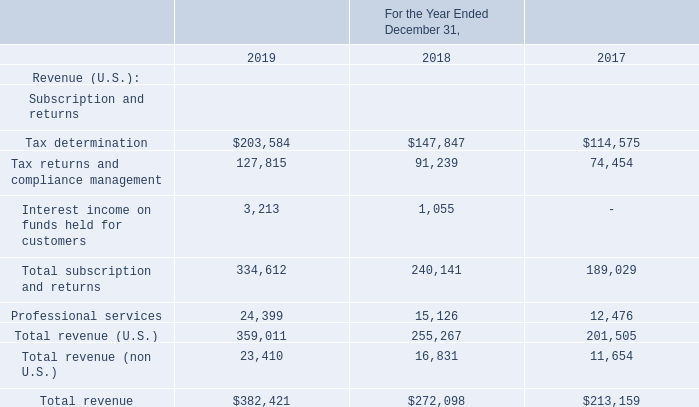Disaggregation of Revenue
The following table disaggregates revenue generated within the United States (U.S.) from revenue generated from customers outside of the U.S. Revenue
for transaction tax compliance in the U.S. is further disaggregated based on the solutions or services purchased by customers. Total revenues consisted of the
following (in thousands):
What are the total revenue earned in 2017 and 2018 respectively?
Answer scale should be: thousand. $213,159, $272,098. What are the total revenue earned in 2019 and 2018 respectively?
Answer scale should be: thousand. $382,421, $272,098. What are the revenue generated from the U.S. in 2018 and 2019 respectively?
Answer scale should be: thousand. 255,267, 359,011. What is the percentage change in total revenue between 2017 and 2018?
Answer scale should be: percent. (272,098 - 213,159)/213,159 
Answer: 27.65. What is the percentage change in total revenue between 2018 and 2019?
Answer scale should be: percent. (382,421 - 272,098)/272,098 
Answer: 40.55. What is the value of the U.S. generated revenue as a percentage of the 2018 total revenue?
Answer scale should be: percent. 255,267/272,098 
Answer: 93.81. 